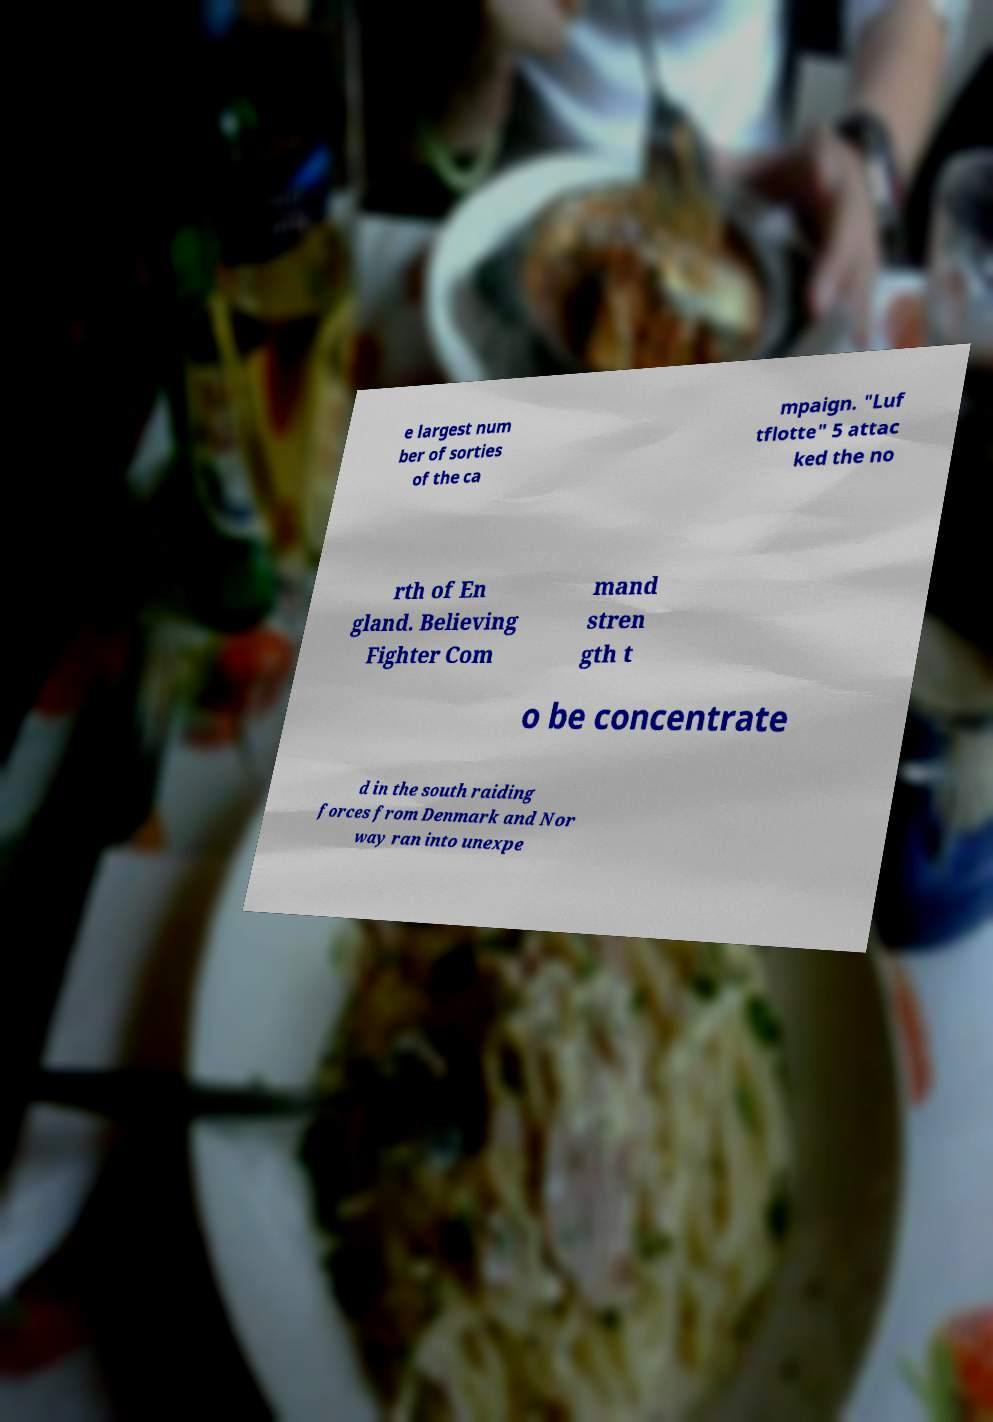Could you extract and type out the text from this image? e largest num ber of sorties of the ca mpaign. "Luf tflotte" 5 attac ked the no rth of En gland. Believing Fighter Com mand stren gth t o be concentrate d in the south raiding forces from Denmark and Nor way ran into unexpe 